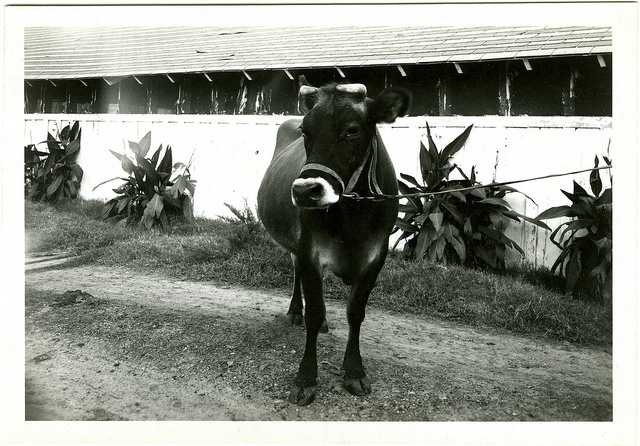Describe the objects in this image and their specific colors. I can see cow in white, black, gray, and darkgray tones, potted plant in white, black, gray, and darkgray tones, potted plant in white, black, gray, and darkgray tones, and potted plant in white, black, gray, and darkgray tones in this image. 